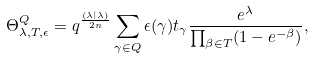<formula> <loc_0><loc_0><loc_500><loc_500>\Theta ^ { Q } _ { \lambda , T , \epsilon } = q ^ { \frac { ( \lambda | \lambda ) } { 2 n } } \sum _ { \gamma \in Q } \epsilon ( \gamma ) t _ { \gamma } \frac { e ^ { \lambda } } { \prod _ { \beta \in T } ( 1 - e ^ { - \beta } ) } ,</formula> 